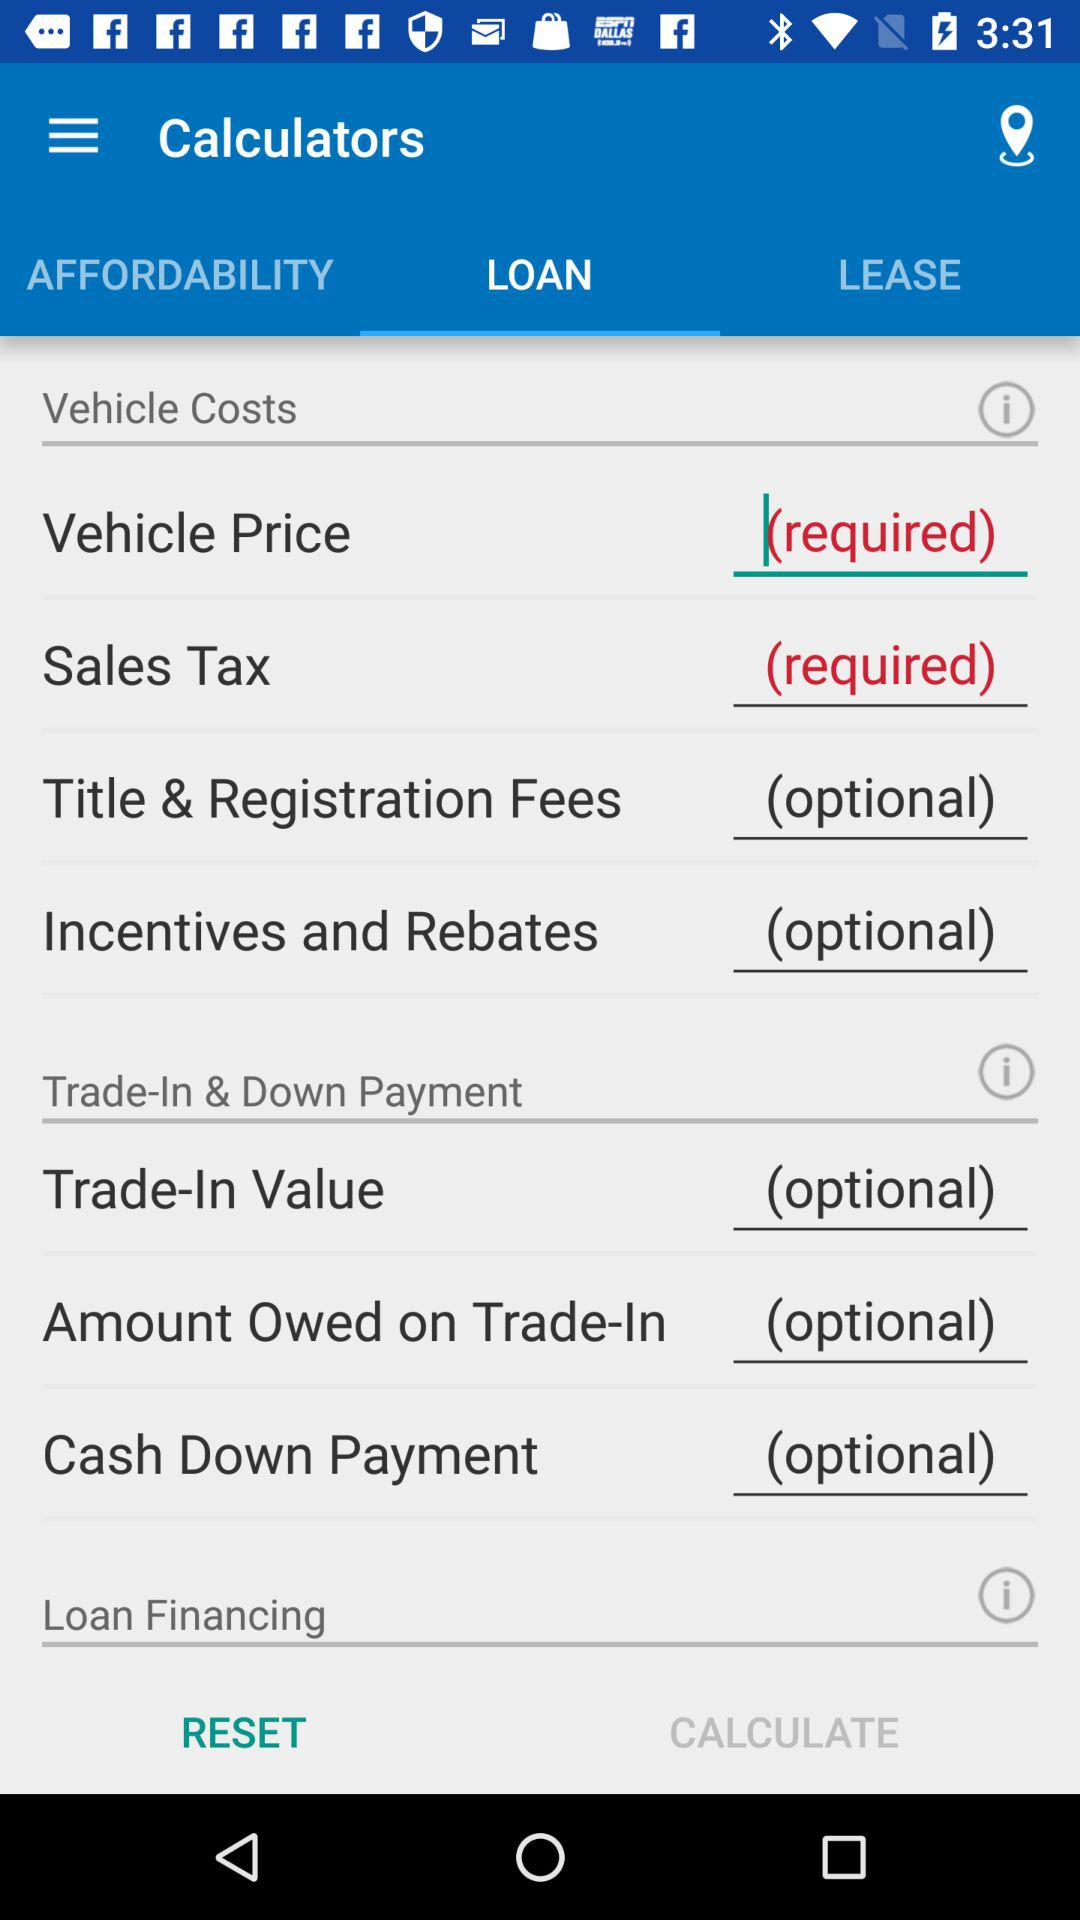Which tab has been selected? The selected tab is "LOAN". 